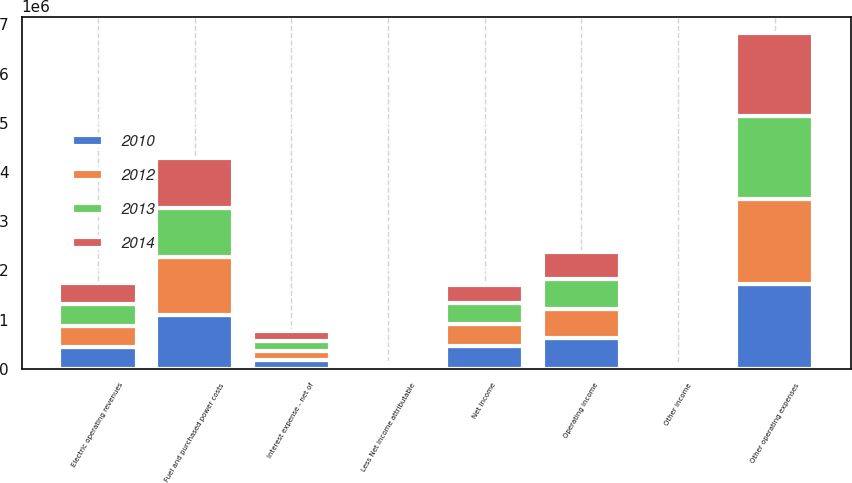Convert chart. <chart><loc_0><loc_0><loc_500><loc_500><stacked_bar_chart><ecel><fcel>Electric operating revenues<fcel>Fuel and purchased power costs<fcel>Other operating expenses<fcel>Operating income<fcel>Other income<fcel>Interest expense - net of<fcel>Net income<fcel>Less Net income attributable<nl><fcel>2012<fcel>437215<fcel>1.17983e+06<fcel>1.71632e+06<fcel>592792<fcel>36358<fcel>181830<fcel>447320<fcel>26101<nl><fcel>2010<fcel>437215<fcel>1.09571e+06<fcel>1.73368e+06<fcel>621865<fcel>20797<fcel>183801<fcel>458861<fcel>33892<nl><fcel>2013<fcel>437215<fcel>994790<fcel>1.69317e+06<fcel>605529<fcel>16358<fcel>194777<fcel>427110<fcel>31613<nl><fcel>2014<fcel>437215<fcel>1.00946e+06<fcel>1.67339e+06<fcel>554383<fcel>24974<fcel>215584<fcel>363773<fcel>27524<nl></chart> 